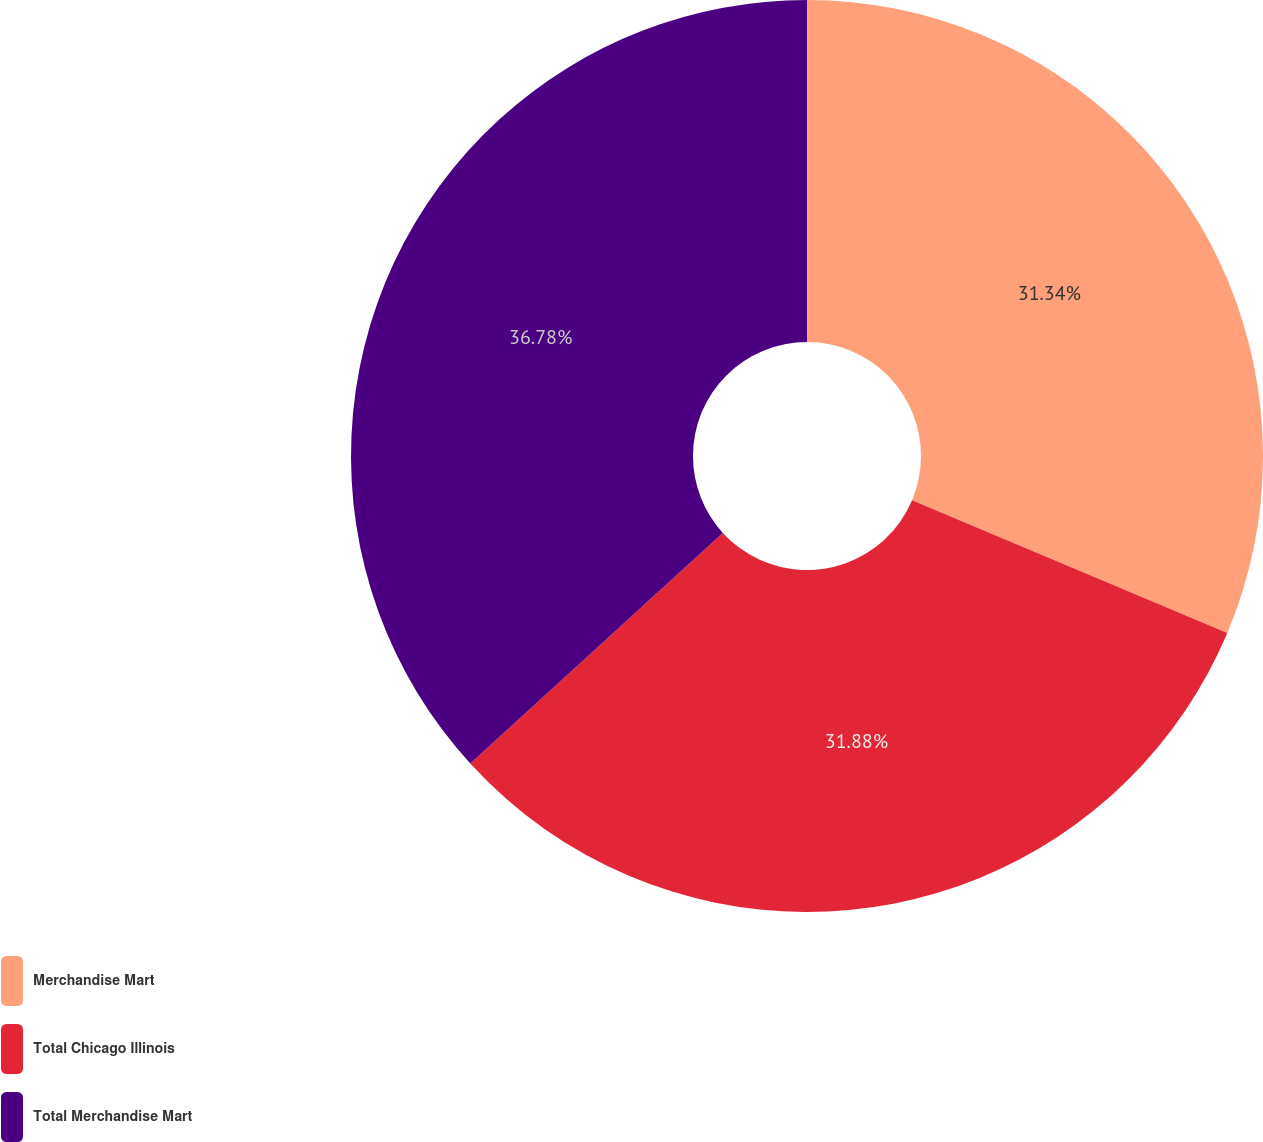<chart> <loc_0><loc_0><loc_500><loc_500><pie_chart><fcel>Merchandise Mart<fcel>Total Chicago Illinois<fcel>Total Merchandise Mart<nl><fcel>31.34%<fcel>31.88%<fcel>36.78%<nl></chart> 